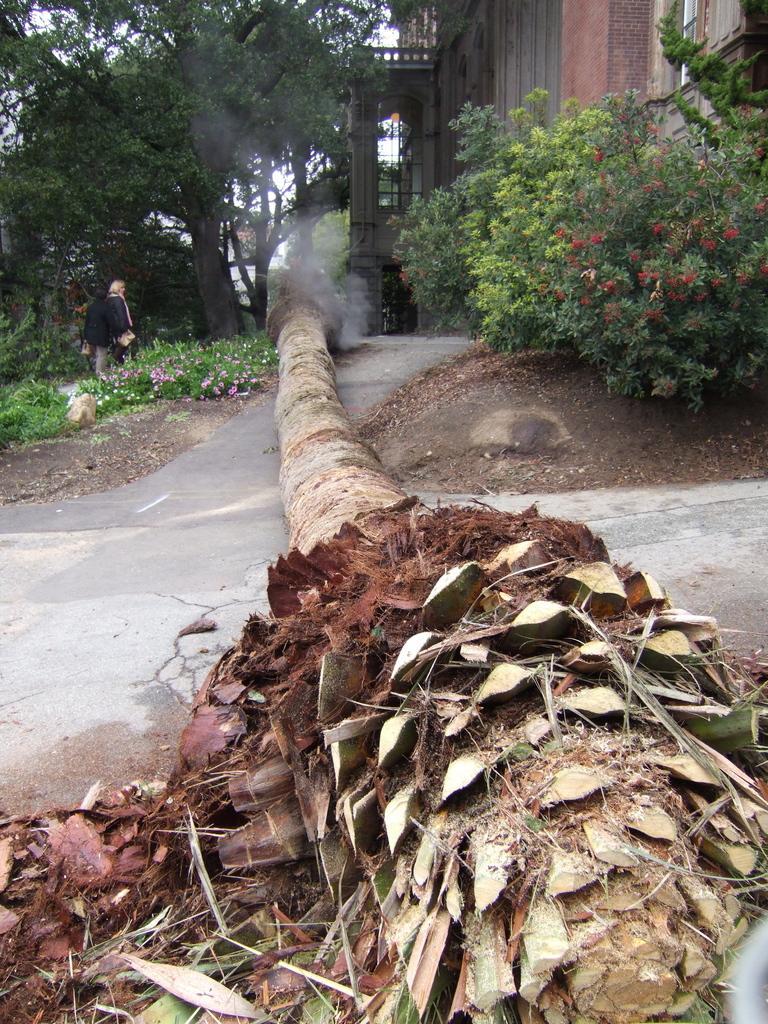Please provide a concise description of this image. In the center of the image we can see one tree has fallen down. In the background, we can see the sky, trees, plants, flowers, one building, one person standing and a few other objects. 